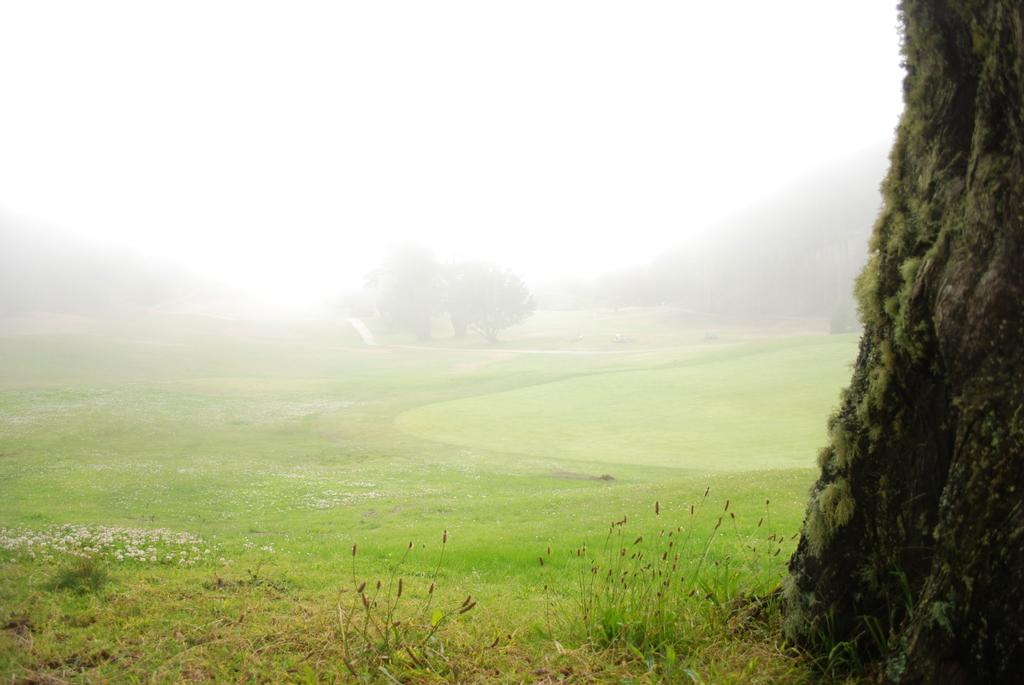What type of vegetation can be seen in the image? There are trees, plants, and grass visible in the image. What kind of landscape feature is present in the image? There are hills in the image. What part of the natural environment is visible in the image? The sky is visible in the image. Reasoning: Let's think step by step by step in order to produce the conversation. We start by identifying the main types of vegetation in the image, which include trees, plants, and grass. Then, we mention the presence of hills as a landscape feature. Finally, we acknowledge the visibility of the sky, which is part of the natural environment. Absurd Question/Answer: What type of juice can be seen being poured from an umbrella in the image? There is no umbrella or juice present in the image. What kind of turkey can be seen grazing on the grass in the image? There is no turkey present in the image; it features trees, plants, grass, hills, and the sky. 